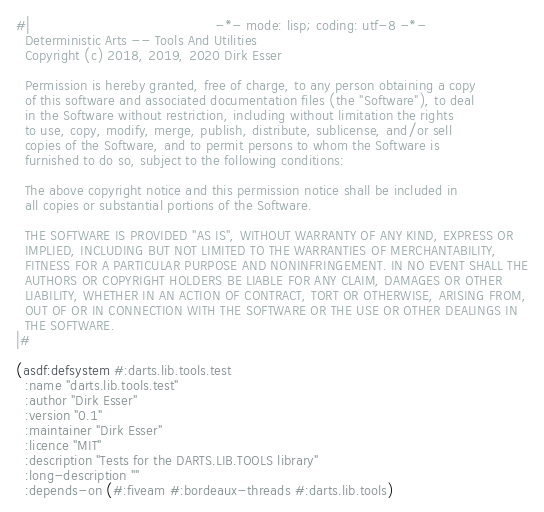Convert code to text. <code><loc_0><loc_0><loc_500><loc_500><_Lisp_>#|                                           -*- mode: lisp; coding: utf-8 -*-
  Deterministic Arts -- Tools And Utilities
  Copyright (c) 2018, 2019, 2020 Dirk Esser

  Permission is hereby granted, free of charge, to any person obtaining a copy
  of this software and associated documentation files (the "Software"), to deal
  in the Software without restriction, including without limitation the rights
  to use, copy, modify, merge, publish, distribute, sublicense, and/or sell
  copies of the Software, and to permit persons to whom the Software is
  furnished to do so, subject to the following conditions:

  The above copyright notice and this permission notice shall be included in
  all copies or substantial portions of the Software.

  THE SOFTWARE IS PROVIDED "AS IS", WITHOUT WARRANTY OF ANY KIND, EXPRESS OR
  IMPLIED, INCLUDING BUT NOT LIMITED TO THE WARRANTIES OF MERCHANTABILITY,
  FITNESS FOR A PARTICULAR PURPOSE AND NONINFRINGEMENT. IN NO EVENT SHALL THE
  AUTHORS OR COPYRIGHT HOLDERS BE LIABLE FOR ANY CLAIM, DAMAGES OR OTHER
  LIABILITY, WHETHER IN AN ACTION OF CONTRACT, TORT OR OTHERWISE, ARISING FROM,
  OUT OF OR IN CONNECTION WITH THE SOFTWARE OR THE USE OR OTHER DEALINGS IN
  THE SOFTWARE.
|#

(asdf:defsystem #:darts.lib.tools.test
  :name "darts.lib.tools.test"
  :author "Dirk Esser"
  :version "0.1"
  :maintainer "Dirk Esser"
  :licence "MIT"
  :description "Tests for the DARTS.LIB.TOOLS library"
  :long-description ""
  :depends-on (#:fiveam #:bordeaux-threads #:darts.lib.tools)</code> 